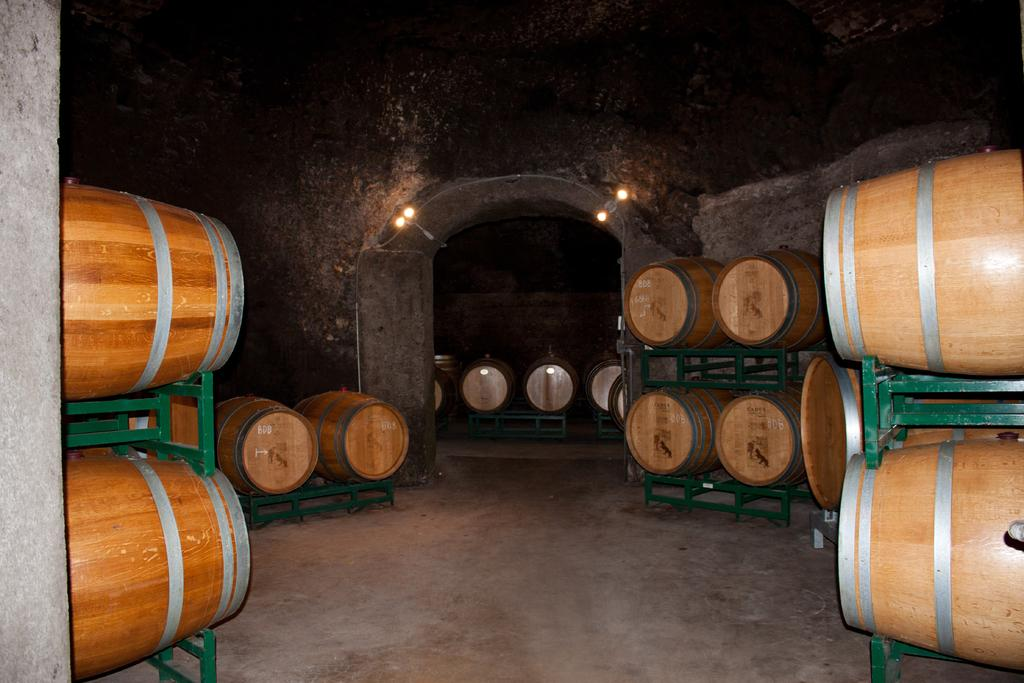What objects are on stands in the image? There are barrels on stands in the image. What type of structure can be seen in the image? There is a wall in the image. What can be used for illumination in the image? There are lights in the image. What surface is visible at the bottom of the image? There is a floor visible at the bottom of the image. How many giants are visible in the image? There are no giants present in the image. What type of event is taking place in the image? There is no event depicted in the image; it simply shows barrels on stands, a wall, lights, and a floor. 